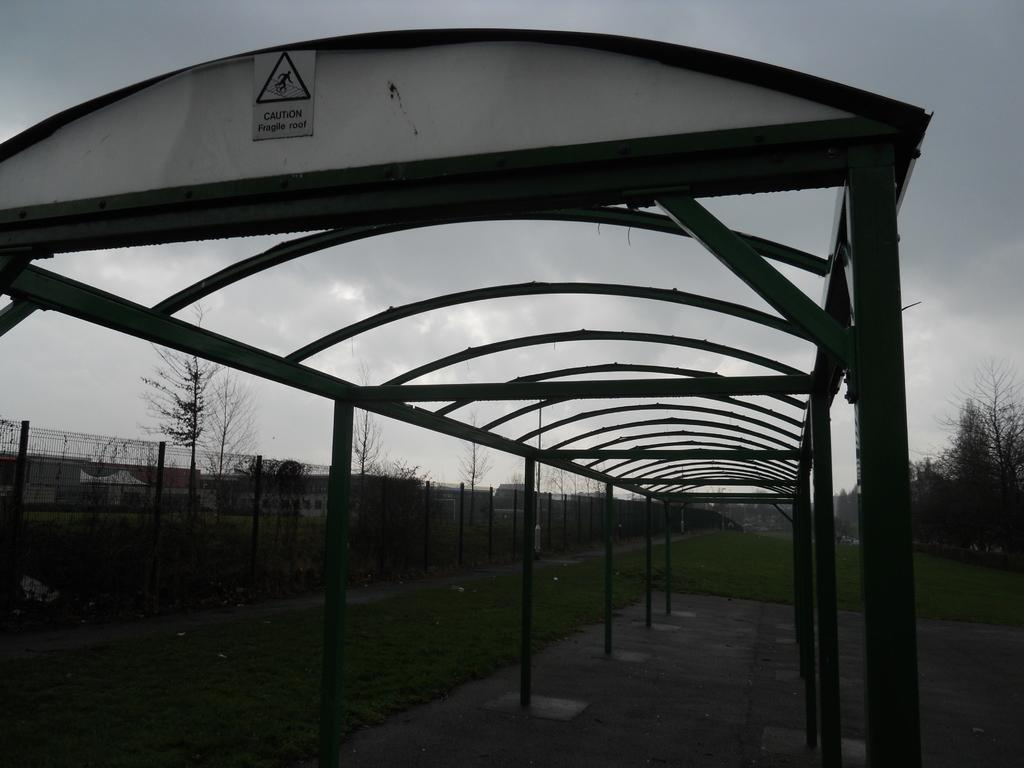What type of structure is present in the image? There is a shed in the image. What is written on the shed? There is text written on the shed. What type of vegetation can be seen in the image? There are trees in the image. What type of ground cover is present in the image? There is grass in the image. What type of barrier is visible in the image? There is fencing in the image. What is visible in the background of the image? The sky is visible in the image. How many planes can be seen flying over the shed in the image? There are no planes visible in the image; it only features a shed, trees, grass, fencing, and the sky. What type of bird is sitting on the hen in the image? There is no hen or bird present in the image. 